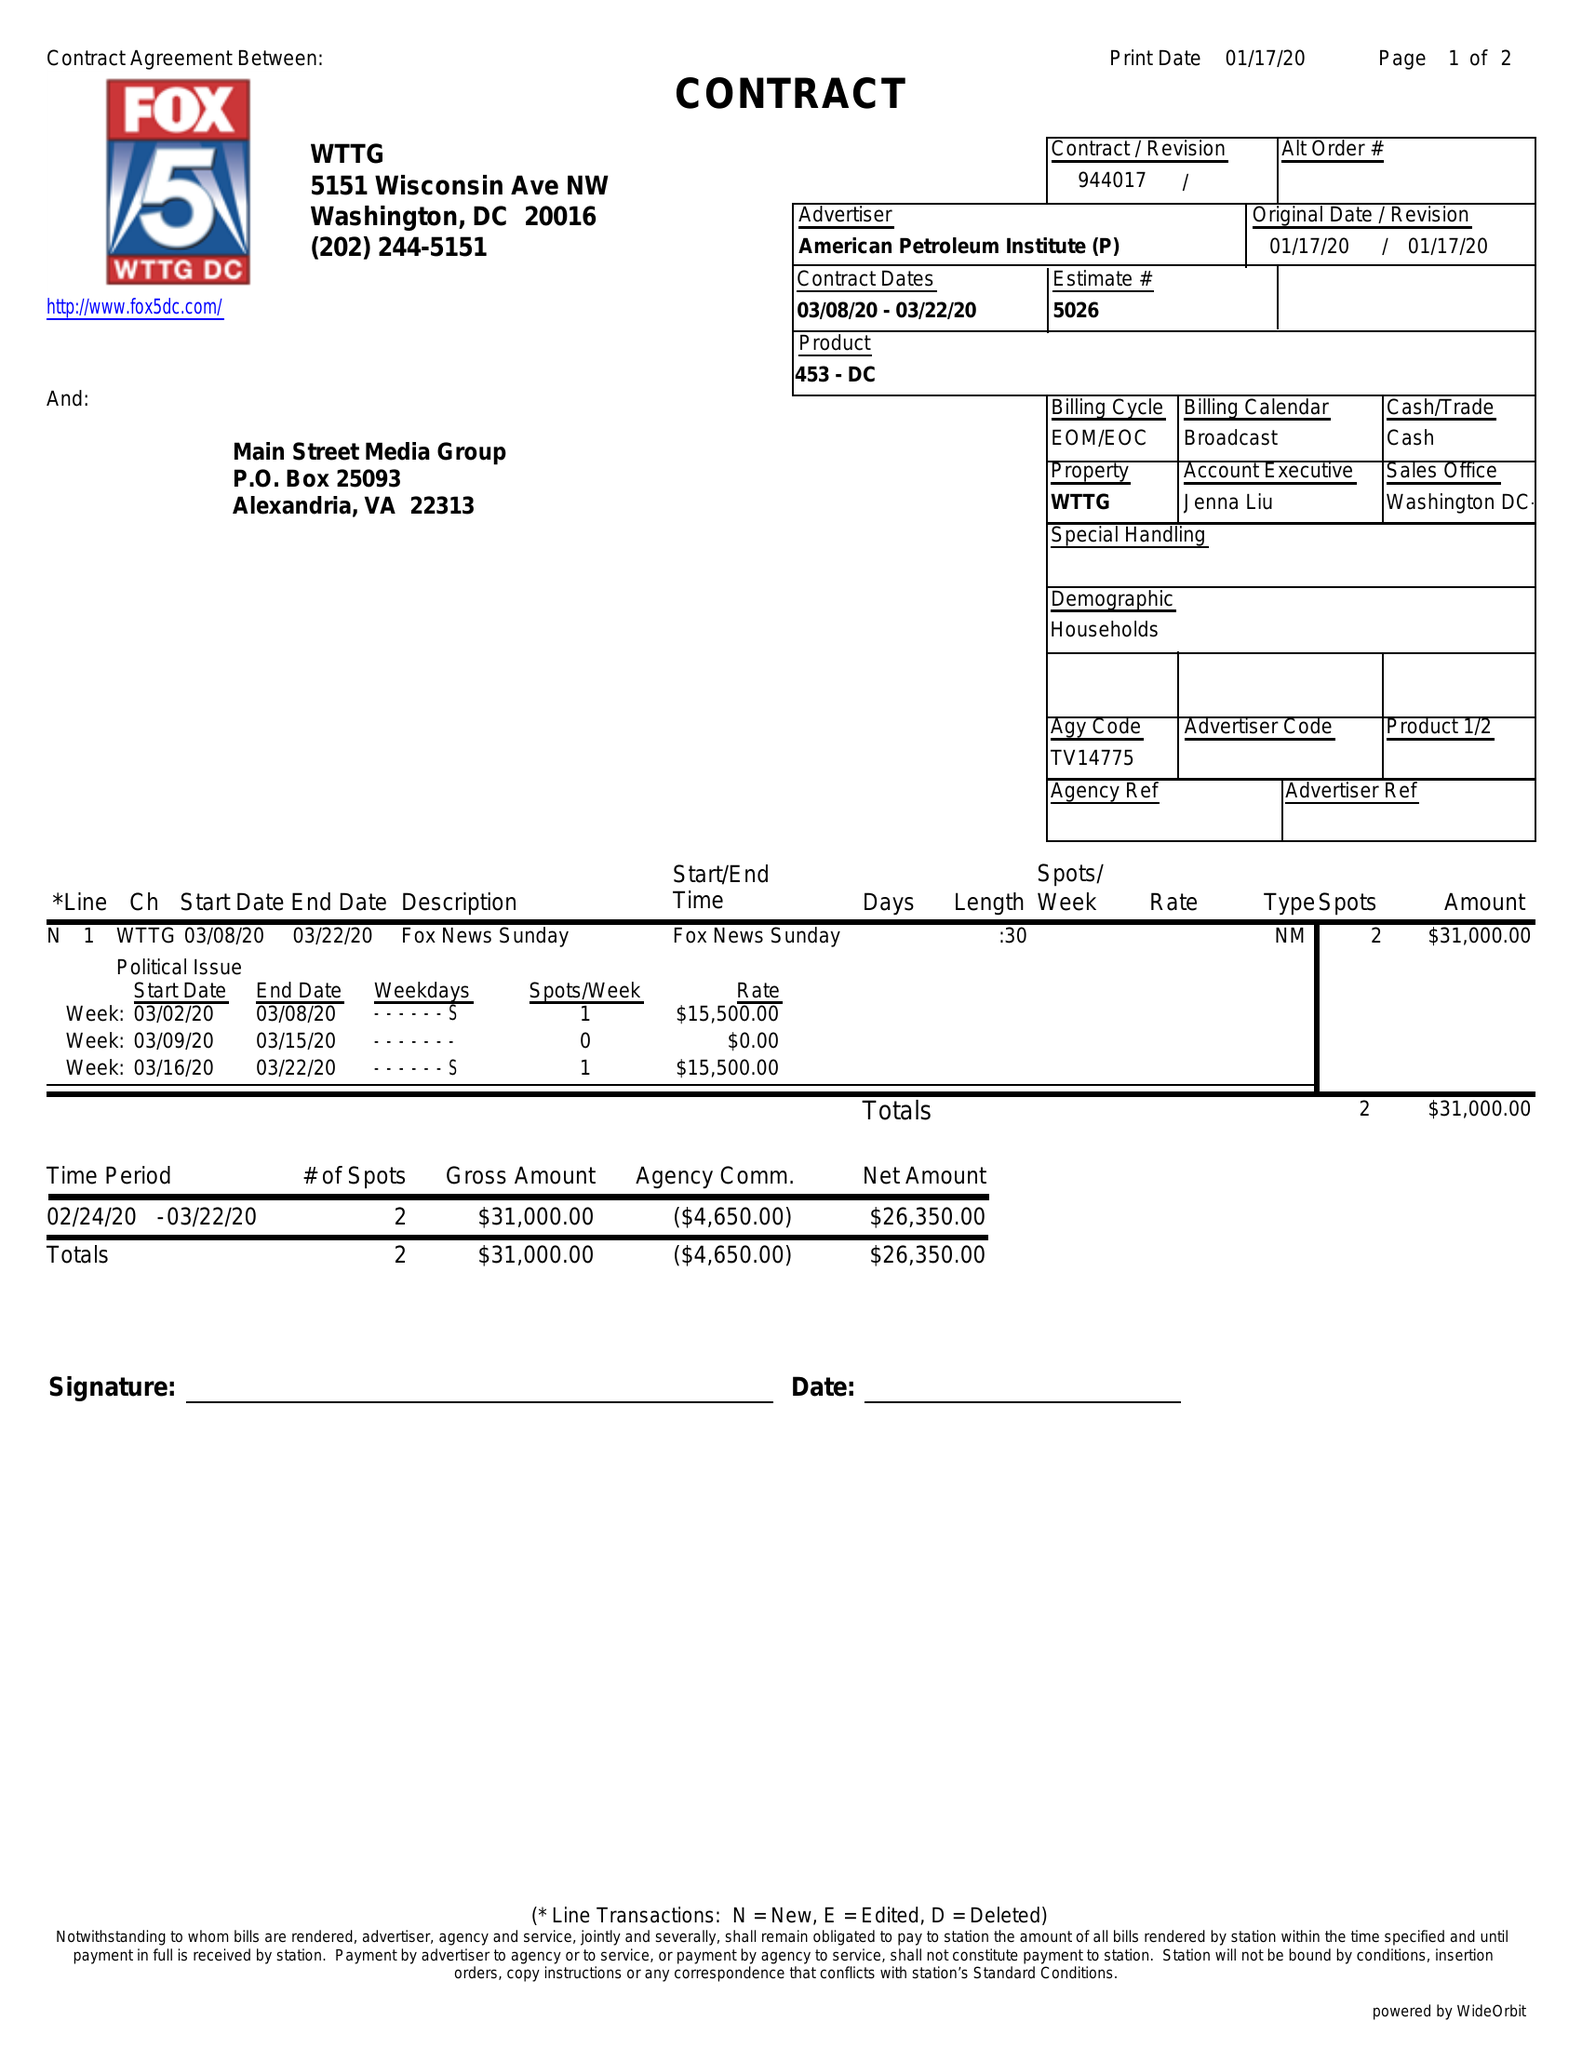What is the value for the flight_from?
Answer the question using a single word or phrase. 03/08/20 